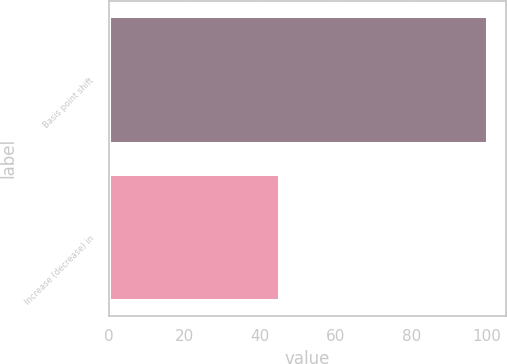Convert chart. <chart><loc_0><loc_0><loc_500><loc_500><bar_chart><fcel>Basis point shift<fcel>Increase (decrease) in<nl><fcel>100<fcel>45<nl></chart> 